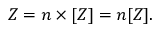<formula> <loc_0><loc_0><loc_500><loc_500>Z = n \times [ Z ] = n [ Z ] .</formula> 